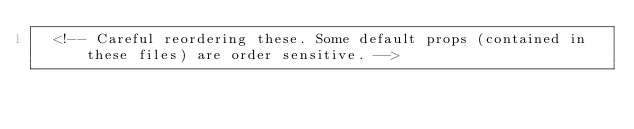<code> <loc_0><loc_0><loc_500><loc_500><_XML_>  <!-- Careful reordering these. Some default props (contained in these files) are order sensitive. --></code> 